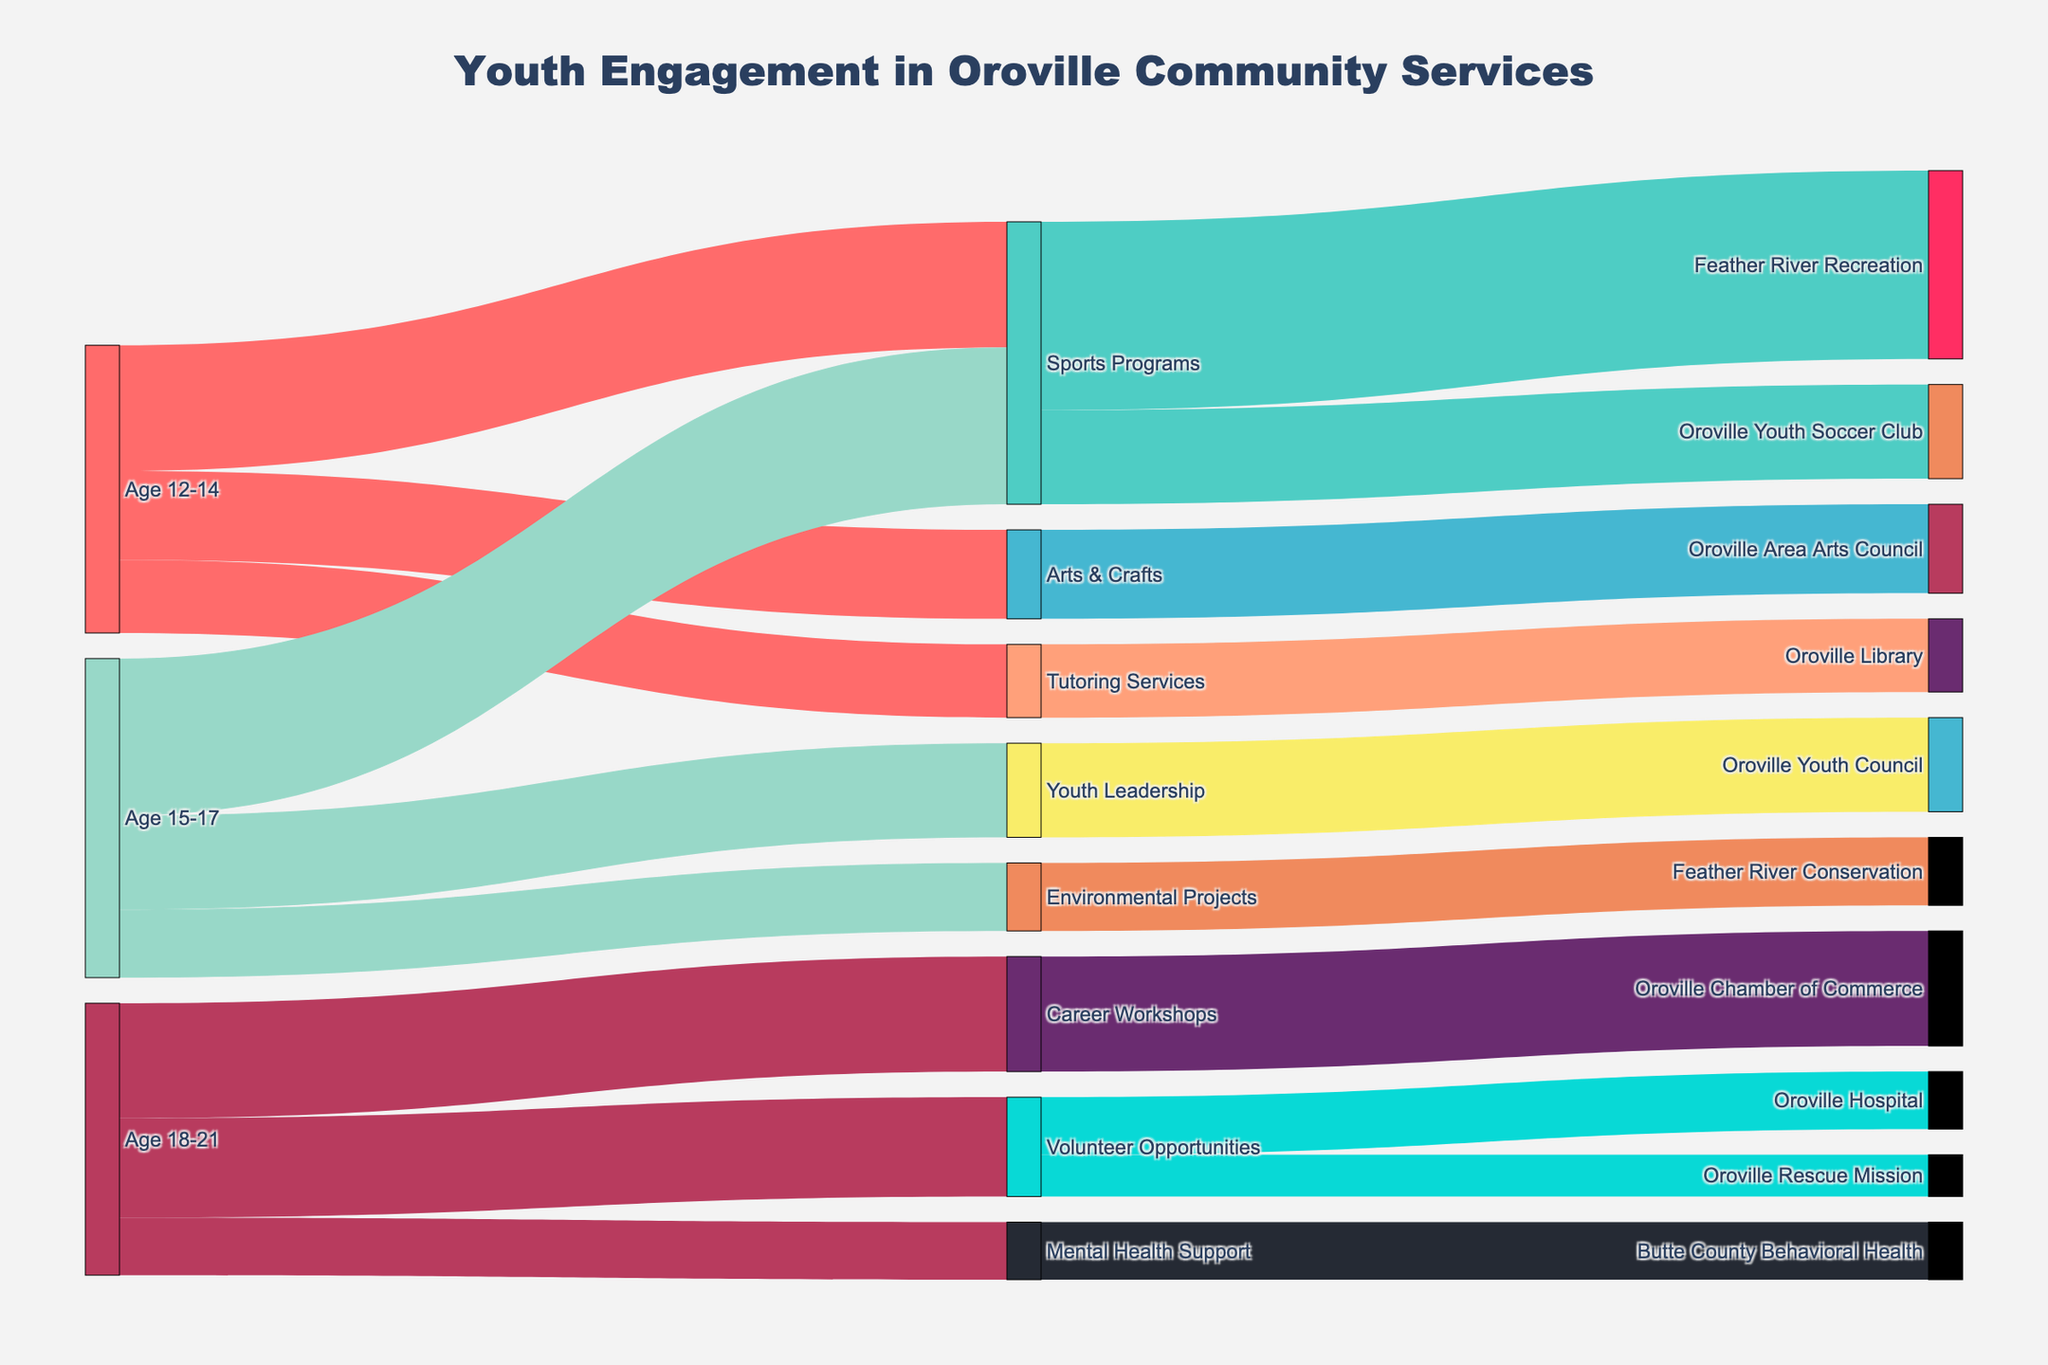what is the title of the figure? The title of the figure should be prominently displayed at the top, indicating the main subject of the diagram.
Answer: Youth Engagement in Oroville Community Services How many different age groups are represented in the diagram? Identify the unique sources related to age groups.
Answer: 3 Which activity type has the highest engagement among age 12-14? Follow the links from the source 'Age 12-14' to various targets, then find the highest value.
Answer: Sports Programs How many youths are engaged in the Oroville Youth Soccer Club through Sports Programs? Find the link that connects 'Sports Programs' with 'Oroville Youth Soccer Club' and read its value.
Answer: 90 Compare the engagement in Environmental Projects and Youth Leadership for age 15-17. Which has more participants? Compare the links from 'Age 15-17' to 'Environmental Projects' and 'Youth Leadership'.
Answer: Youth Leadership How many youths aged 18-21 are involved in Volunteer Opportunities? Look for the link from 'Age 18-21' to 'Volunteer Opportunities' and read its value.
Answer: 95 What is the smallest group size when looking at direct service participation (like Feather River Recreation and Oroville Rescue Mission)? Identify all target groups related to the direct services and find the smallest value among them.
Answer: Oroville Rescue Mission Compare the total engagement in Sports Programs and Arts & Crafts. Which has more total participants? Sum the values of links leading to 'Sports Programs' and 'Arts & Crafts' from all age groups, then compare the totals.
Answer: Sports Programs What is the combined number of youths engaged in Feather River Recreation and Feather River Conservation projects? Sum the engagement values for both 'Feather River Recreation' and 'Feather River Conservation'.
Answer: 245 What proportion of the engaged youth are in Career Workshops compared to Volunteer Opportunities for age 18-21? Compare the participants in 'Career Workshops' and 'Volunteer Opportunities' for age group 18-21, then calculate the ratio.
Answer: 110/95 = 1.16 